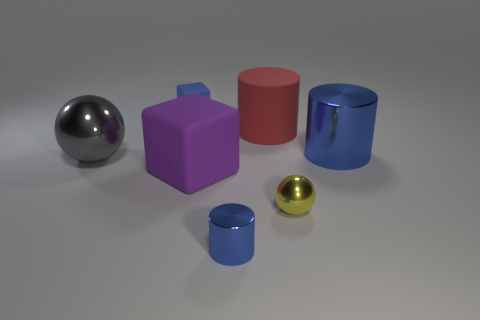Add 2 small brown rubber cubes. How many objects exist? 9 Subtract all spheres. How many objects are left? 5 Add 7 large red things. How many large red things exist? 8 Subtract 1 yellow balls. How many objects are left? 6 Subtract all metallic things. Subtract all rubber cylinders. How many objects are left? 2 Add 5 small blue shiny cylinders. How many small blue shiny cylinders are left? 6 